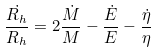<formula> <loc_0><loc_0><loc_500><loc_500>\frac { \dot { R _ { h } } } { R _ { h } } = 2 \frac { \dot { M } } { M } - \frac { \dot { E } } { E } - \frac { \dot { \eta } } { \eta }</formula> 